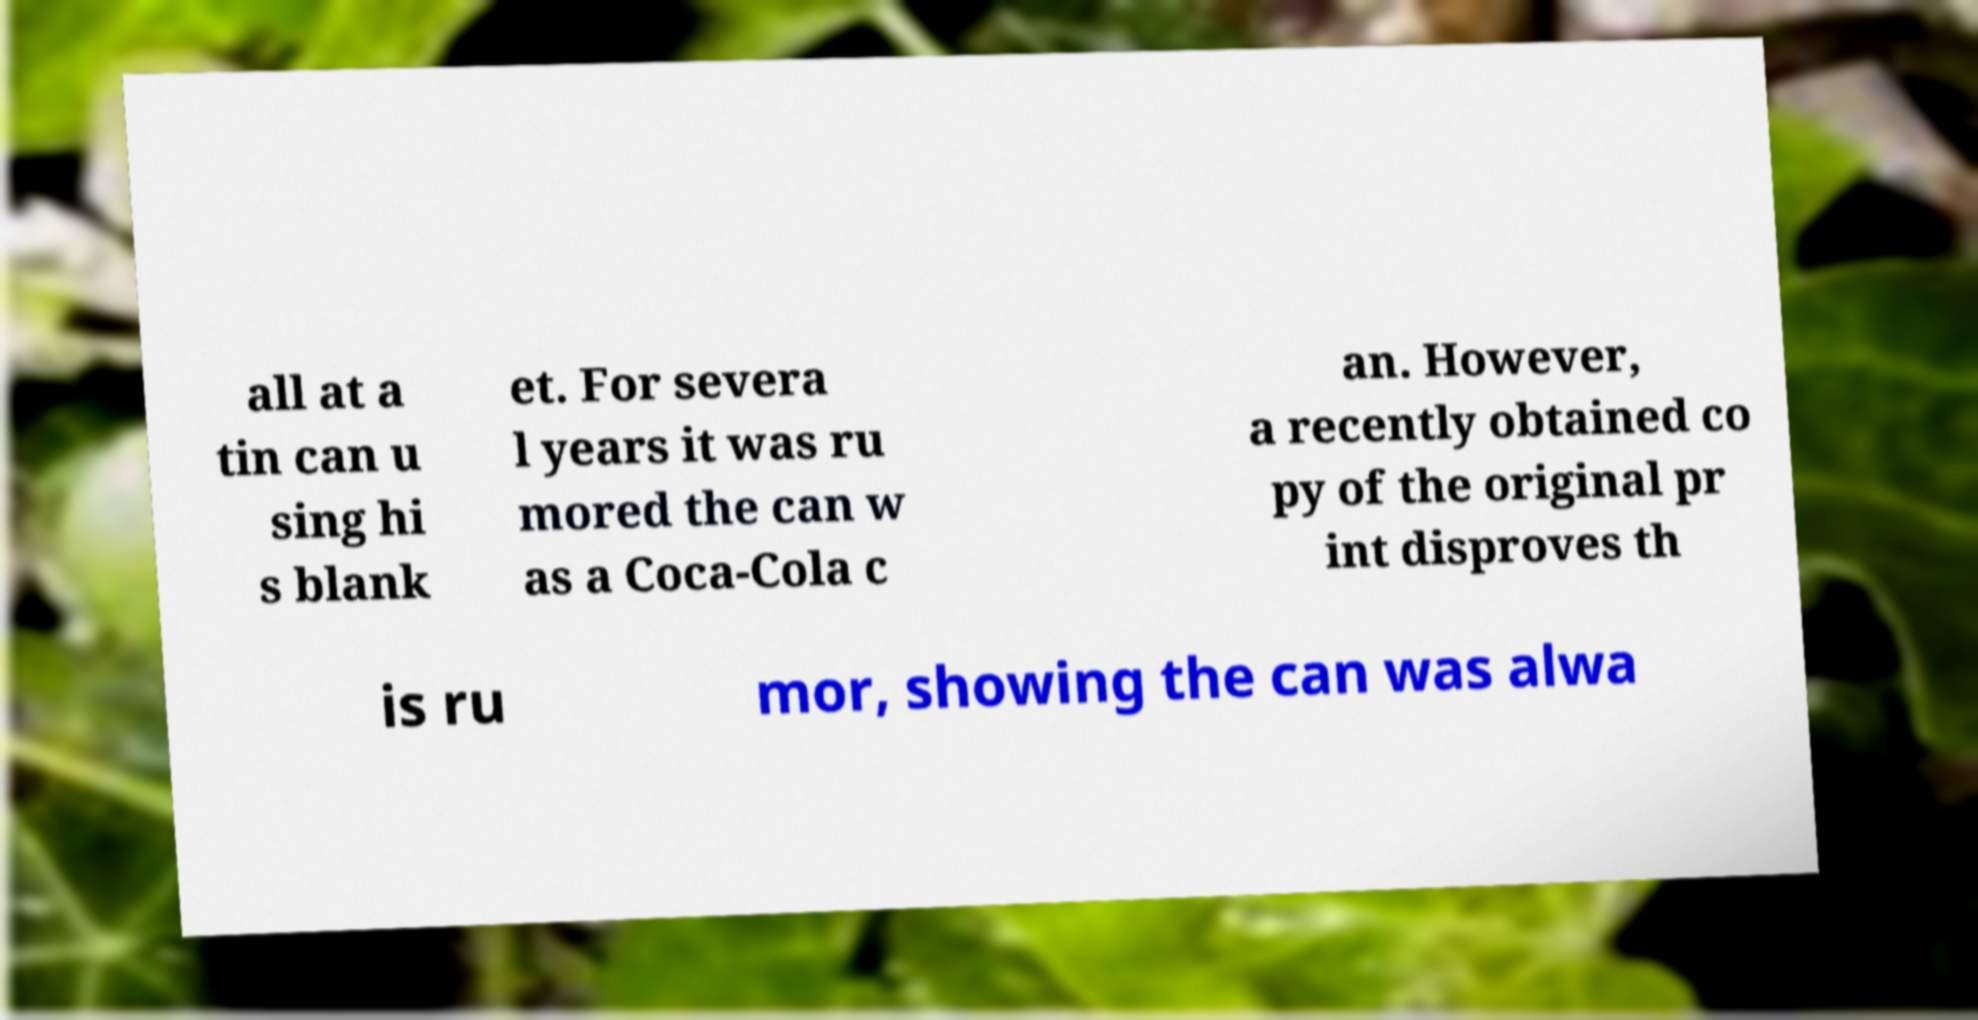There's text embedded in this image that I need extracted. Can you transcribe it verbatim? all at a tin can u sing hi s blank et. For severa l years it was ru mored the can w as a Coca-Cola c an. However, a recently obtained co py of the original pr int disproves th is ru mor, showing the can was alwa 